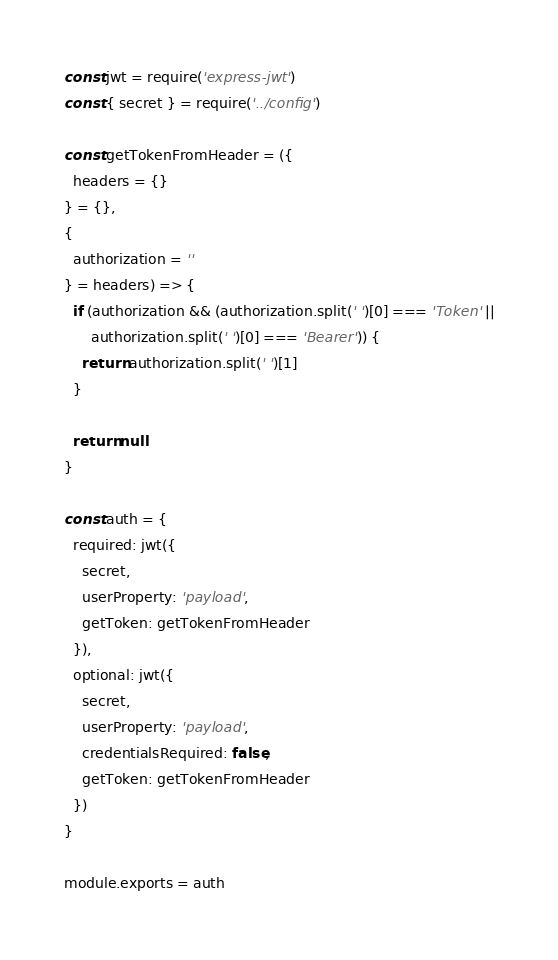<code> <loc_0><loc_0><loc_500><loc_500><_JavaScript_>const jwt = require('express-jwt')
const { secret } = require('../config')

const getTokenFromHeader = ({
  headers = {}
} = {},
{
  authorization = ''
} = headers) => {
  if (authorization && (authorization.split(' ')[0] === 'Token' ||
      authorization.split(' ')[0] === 'Bearer')) {
    return authorization.split(' ')[1]
  }

  return null
}

const auth = {
  required: jwt({
    secret,
    userProperty: 'payload',
    getToken: getTokenFromHeader
  }),
  optional: jwt({
    secret,
    userProperty: 'payload',
    credentialsRequired: false,
    getToken: getTokenFromHeader
  })
}

module.exports = auth
</code> 